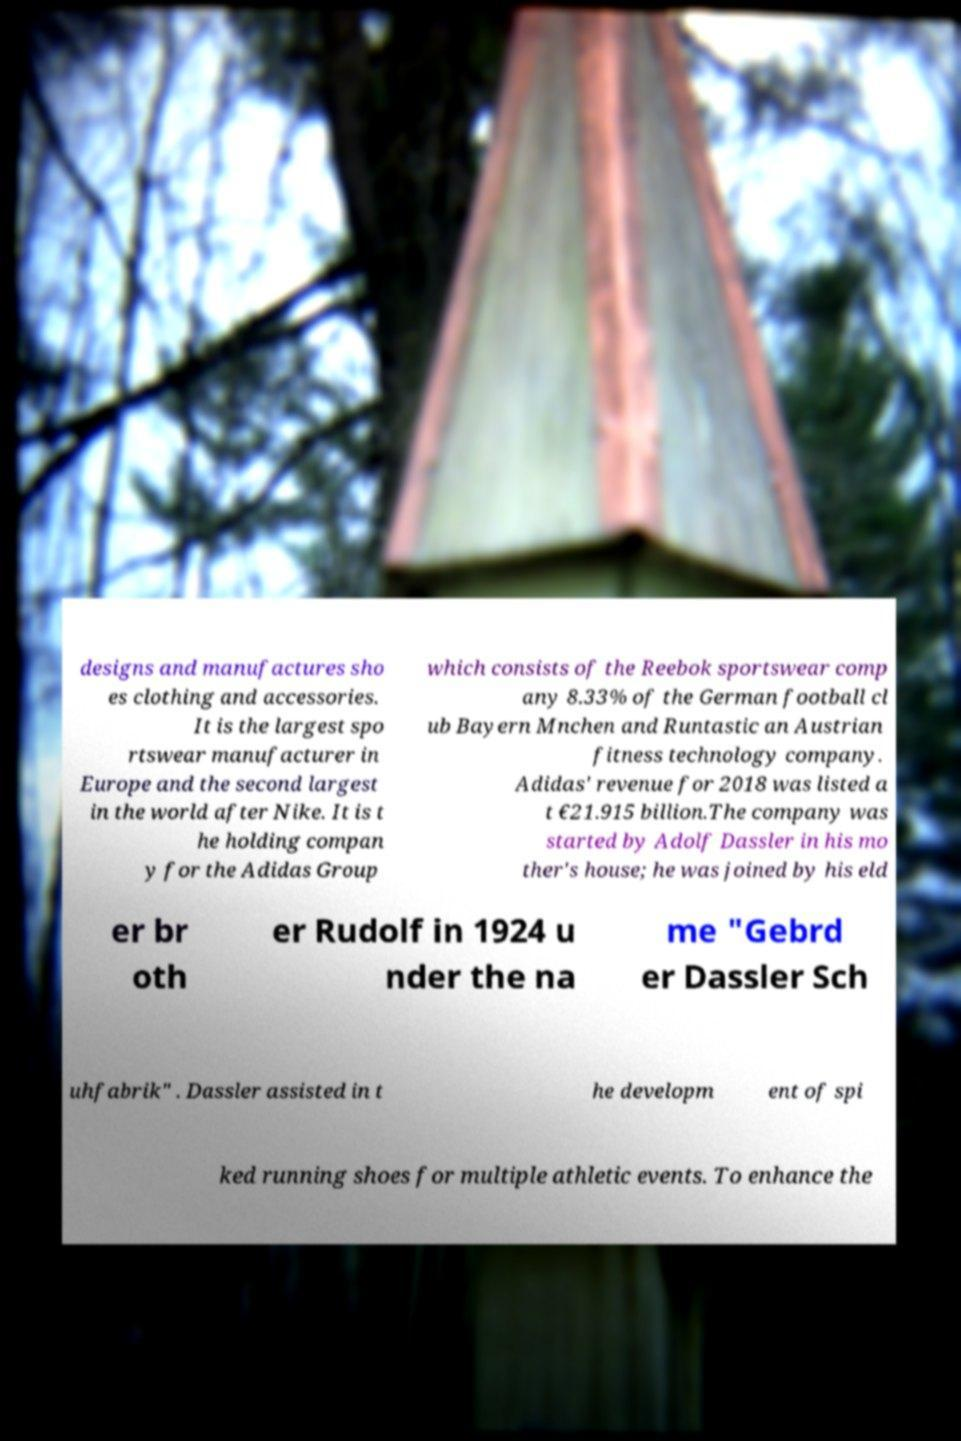Can you read and provide the text displayed in the image?This photo seems to have some interesting text. Can you extract and type it out for me? designs and manufactures sho es clothing and accessories. It is the largest spo rtswear manufacturer in Europe and the second largest in the world after Nike. It is t he holding compan y for the Adidas Group which consists of the Reebok sportswear comp any 8.33% of the German football cl ub Bayern Mnchen and Runtastic an Austrian fitness technology company. Adidas' revenue for 2018 was listed a t €21.915 billion.The company was started by Adolf Dassler in his mo ther's house; he was joined by his eld er br oth er Rudolf in 1924 u nder the na me "Gebrd er Dassler Sch uhfabrik" . Dassler assisted in t he developm ent of spi ked running shoes for multiple athletic events. To enhance the 